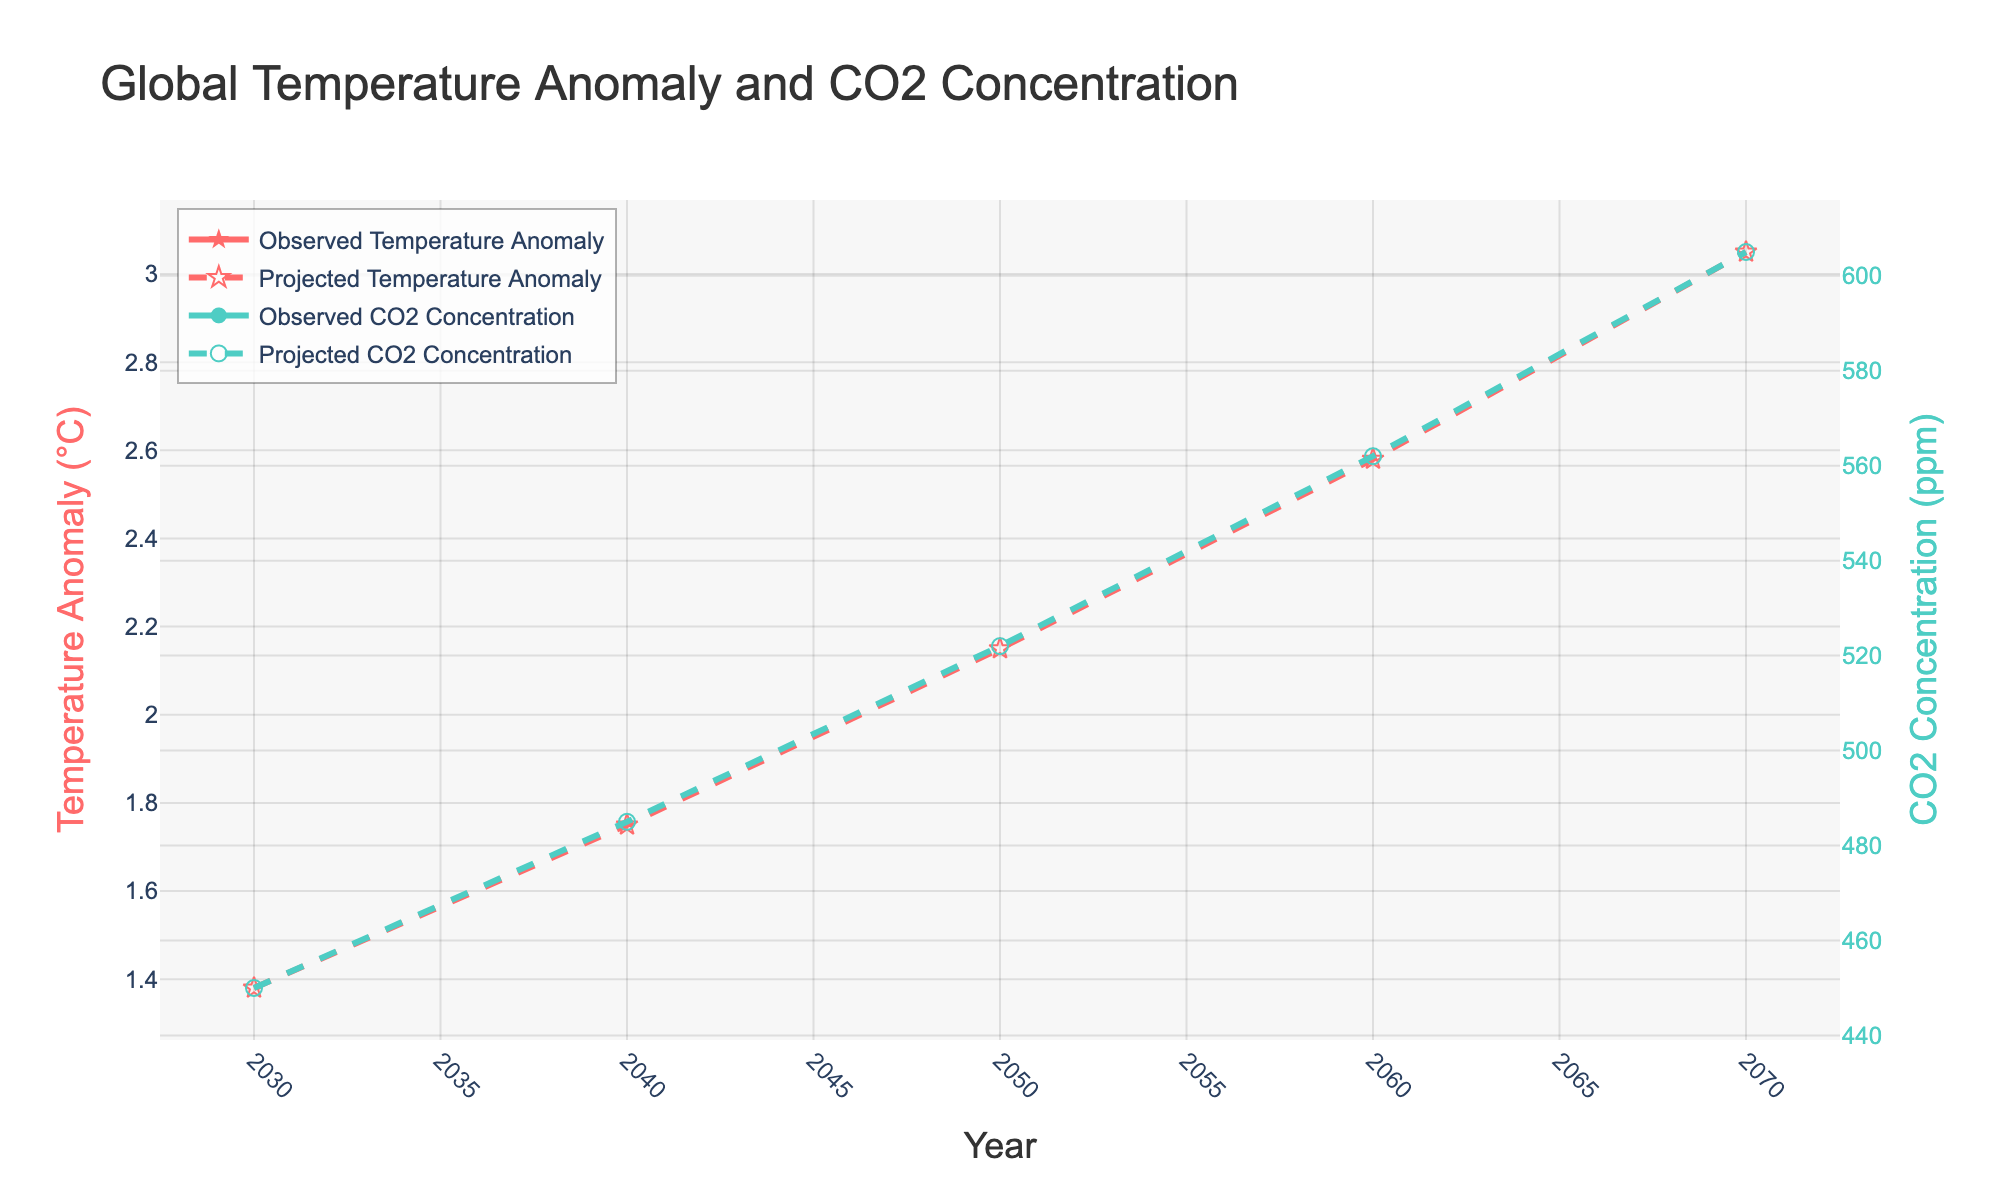What is the projected temperature anomaly in 2050? Look at the dashed red line representing the projected temperature anomalies. Find the data point at the year 2050.
Answer: 2.15°C How much higher is the projected CO2 concentration in 2070 compared to 2030? Compare the dashed green line data points for CO2 concentration at 2070 and 2030. 605 ppm in 2070 minus 450 ppm in 2030 is 605 - 450 = 155.
Answer: 155 ppm What is the difference between the observed and projected temperature anomaly in 2040? Look at the corresponding data points for both solid and dashed red lines for the year 2040. The observed data is not present, so we can only refer to the projected temperature anomaly, which is 1.75°C. Since there is no observed value, the difference can't be calculated.
Answer: Not applicable What is the relationship between projected CO2 concentration and projected temperature anomaly by 2070? Both the temperature anomaly and CO2 concentration increase over time according to their respective dashed red and green lines. By 2070, the temperature anomaly is 3.05°C and CO2 concentration is 605 ppm showing a positive correlation.
Answer: Positive correlation How does the temperature anomaly trend compare with the CO2 concentration trend? Both the red and green lines show an increasing trend over the years. As CO2 concentration increases, the temperature anomaly also rises.
Answer: Both increase What are the projected values for temperature anomaly and CO2 concentration in 2060? Locate the dashed lines at the year 2060 for both temperature anomaly and CO2 concentration. The temperature anomaly is 2.58°C and the CO2 concentration is 562 ppm.
Answer: 2.58°C, 562 ppm By how much is the temperature projected to increase from 2030 to 2070? The projected temperature anomaly for 2030 is 1.38°C and for 2070 is 3.05°C. Subtract the 2030 value from the 2070 value: 3.05 - 1.38 = 1.67
Answer: 1.67°C Is the CO2 concentration projection steeper in the first half of the 21st century or the second half? Compare the slope of the green dashed line from 2030 to 2050 and 2050 to 2070. The latter appears to be steeper, indicating a faster increase in CO2 concentration in the second half of the century.
Answer: Second half Which increases more rapidly, CO2 concentration or temperature anomaly? By visually assessing the slopes of the dashed red and green lines, the green line (CO2 concentration) appears steeper, indicating a more rapid increase compared to the red line (temperature anomaly).
Answer: CO2 concentration From 2030 to 2040, what is the projected increase rate in CO2 concentration per year? The CO2 concentration in 2030 is 450 ppm and in 2040 is 485 ppm. The increase is 485 - 450 = 35 ppm over 10 years. So, the rate is 35 / 10 = 3.5 ppm per year.
Answer: 3.5 ppm/year 